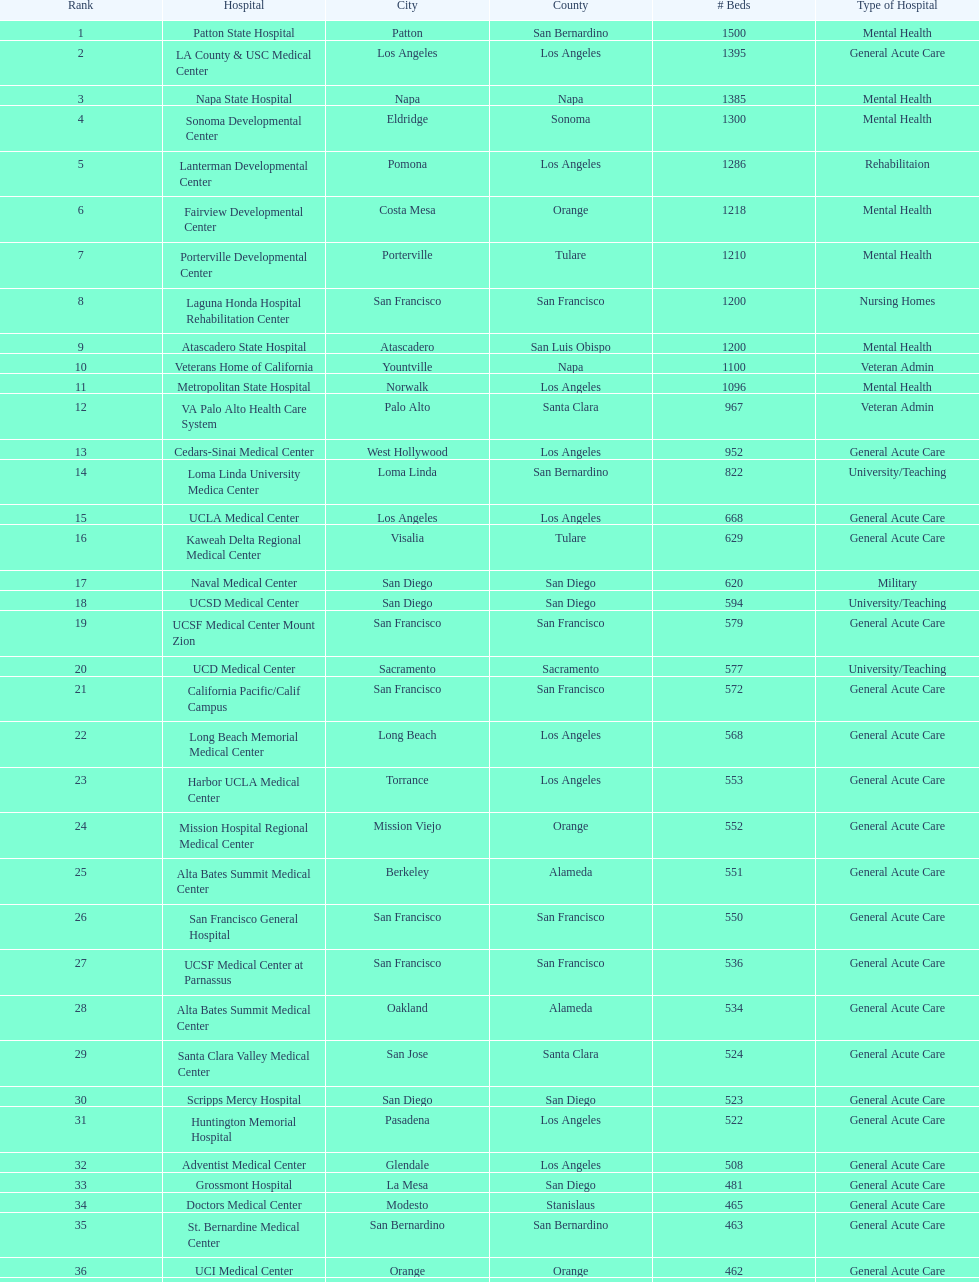Which two hospitals with back-to-back rankings of 8 and 9 respectively, both furnish 1200 hospital beds? Laguna Honda Hospital Rehabilitation Center, Atascadero State Hospital. 